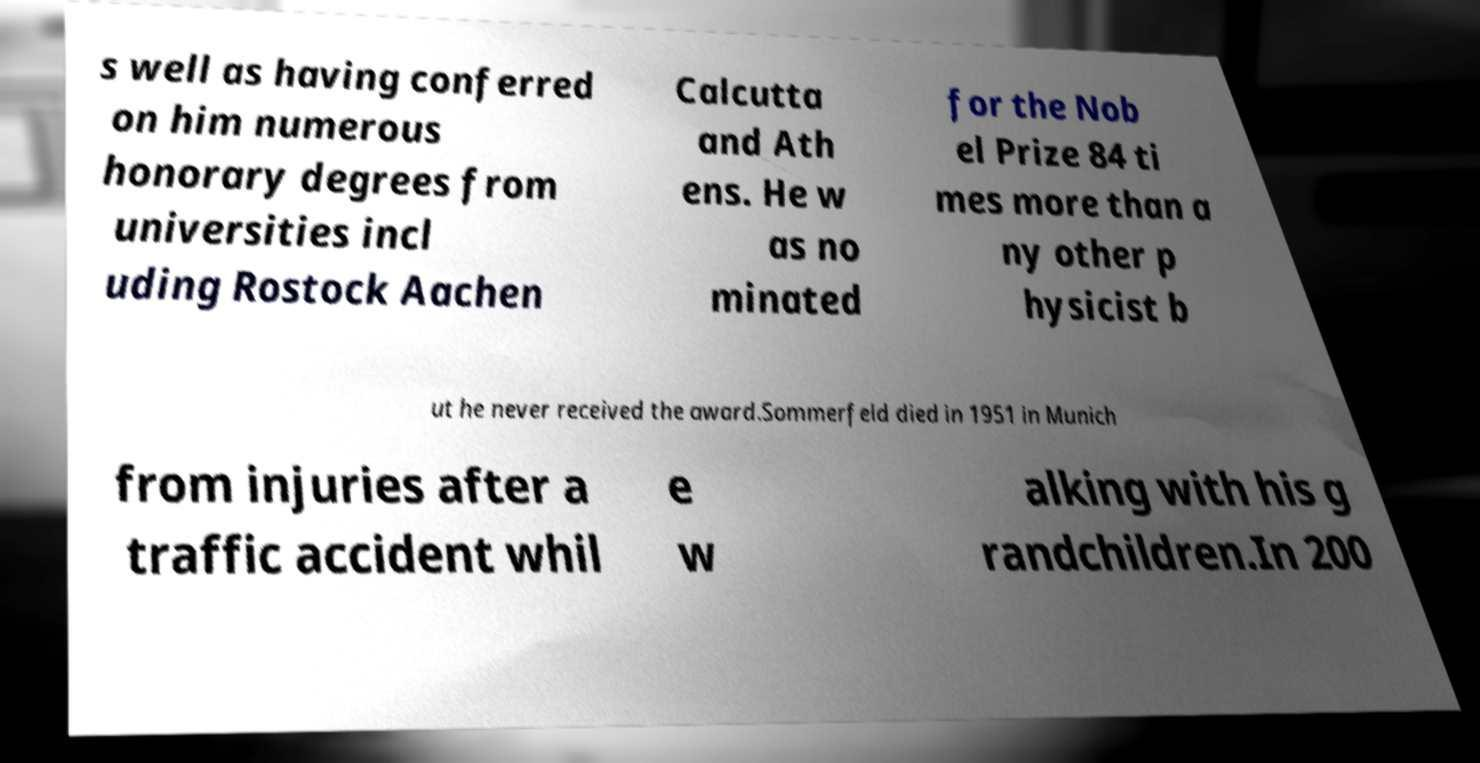What messages or text are displayed in this image? I need them in a readable, typed format. s well as having conferred on him numerous honorary degrees from universities incl uding Rostock Aachen Calcutta and Ath ens. He w as no minated for the Nob el Prize 84 ti mes more than a ny other p hysicist b ut he never received the award.Sommerfeld died in 1951 in Munich from injuries after a traffic accident whil e w alking with his g randchildren.In 200 